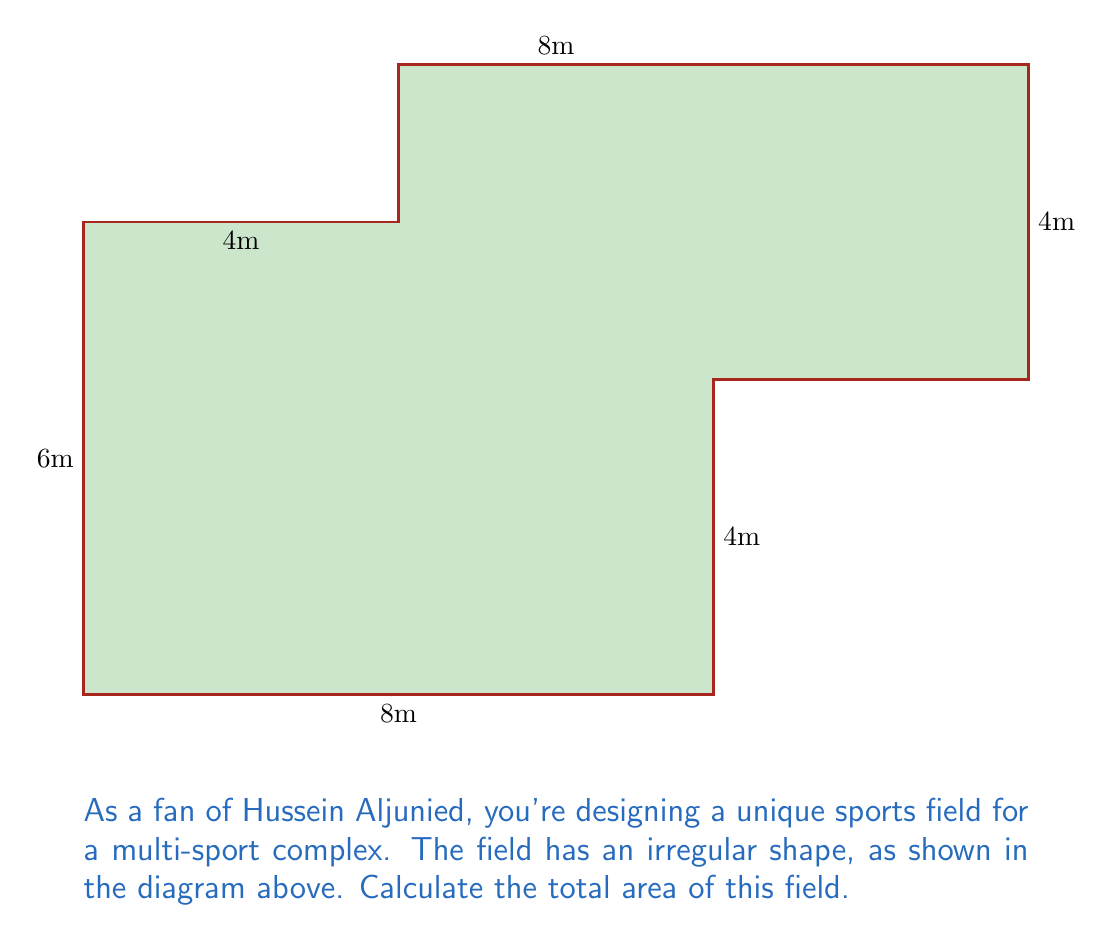Can you answer this question? To calculate the area of this irregular field, we can divide it into rectangles and then sum their areas:

1. Divide the field into three rectangles:
   - Rectangle A: 8m x 6m
   - Rectangle B: 4m x 4m
   - Rectangle C: 4m x 8m

2. Calculate the area of each rectangle:
   - Area of A: $A_A = 8 \times 6 = 48$ m²
   - Area of B: $A_B = 4 \times 4 = 16$ m²
   - Area of C: $A_C = 4 \times 8 = 32$ m²

3. Sum the areas:
   $$A_{total} = A_A + A_B + A_C$$
   $$A_{total} = 48 + 16 + 32 = 96$$ m²

Therefore, the total area of the irregular sports field is 96 square meters.
Answer: 96 m² 